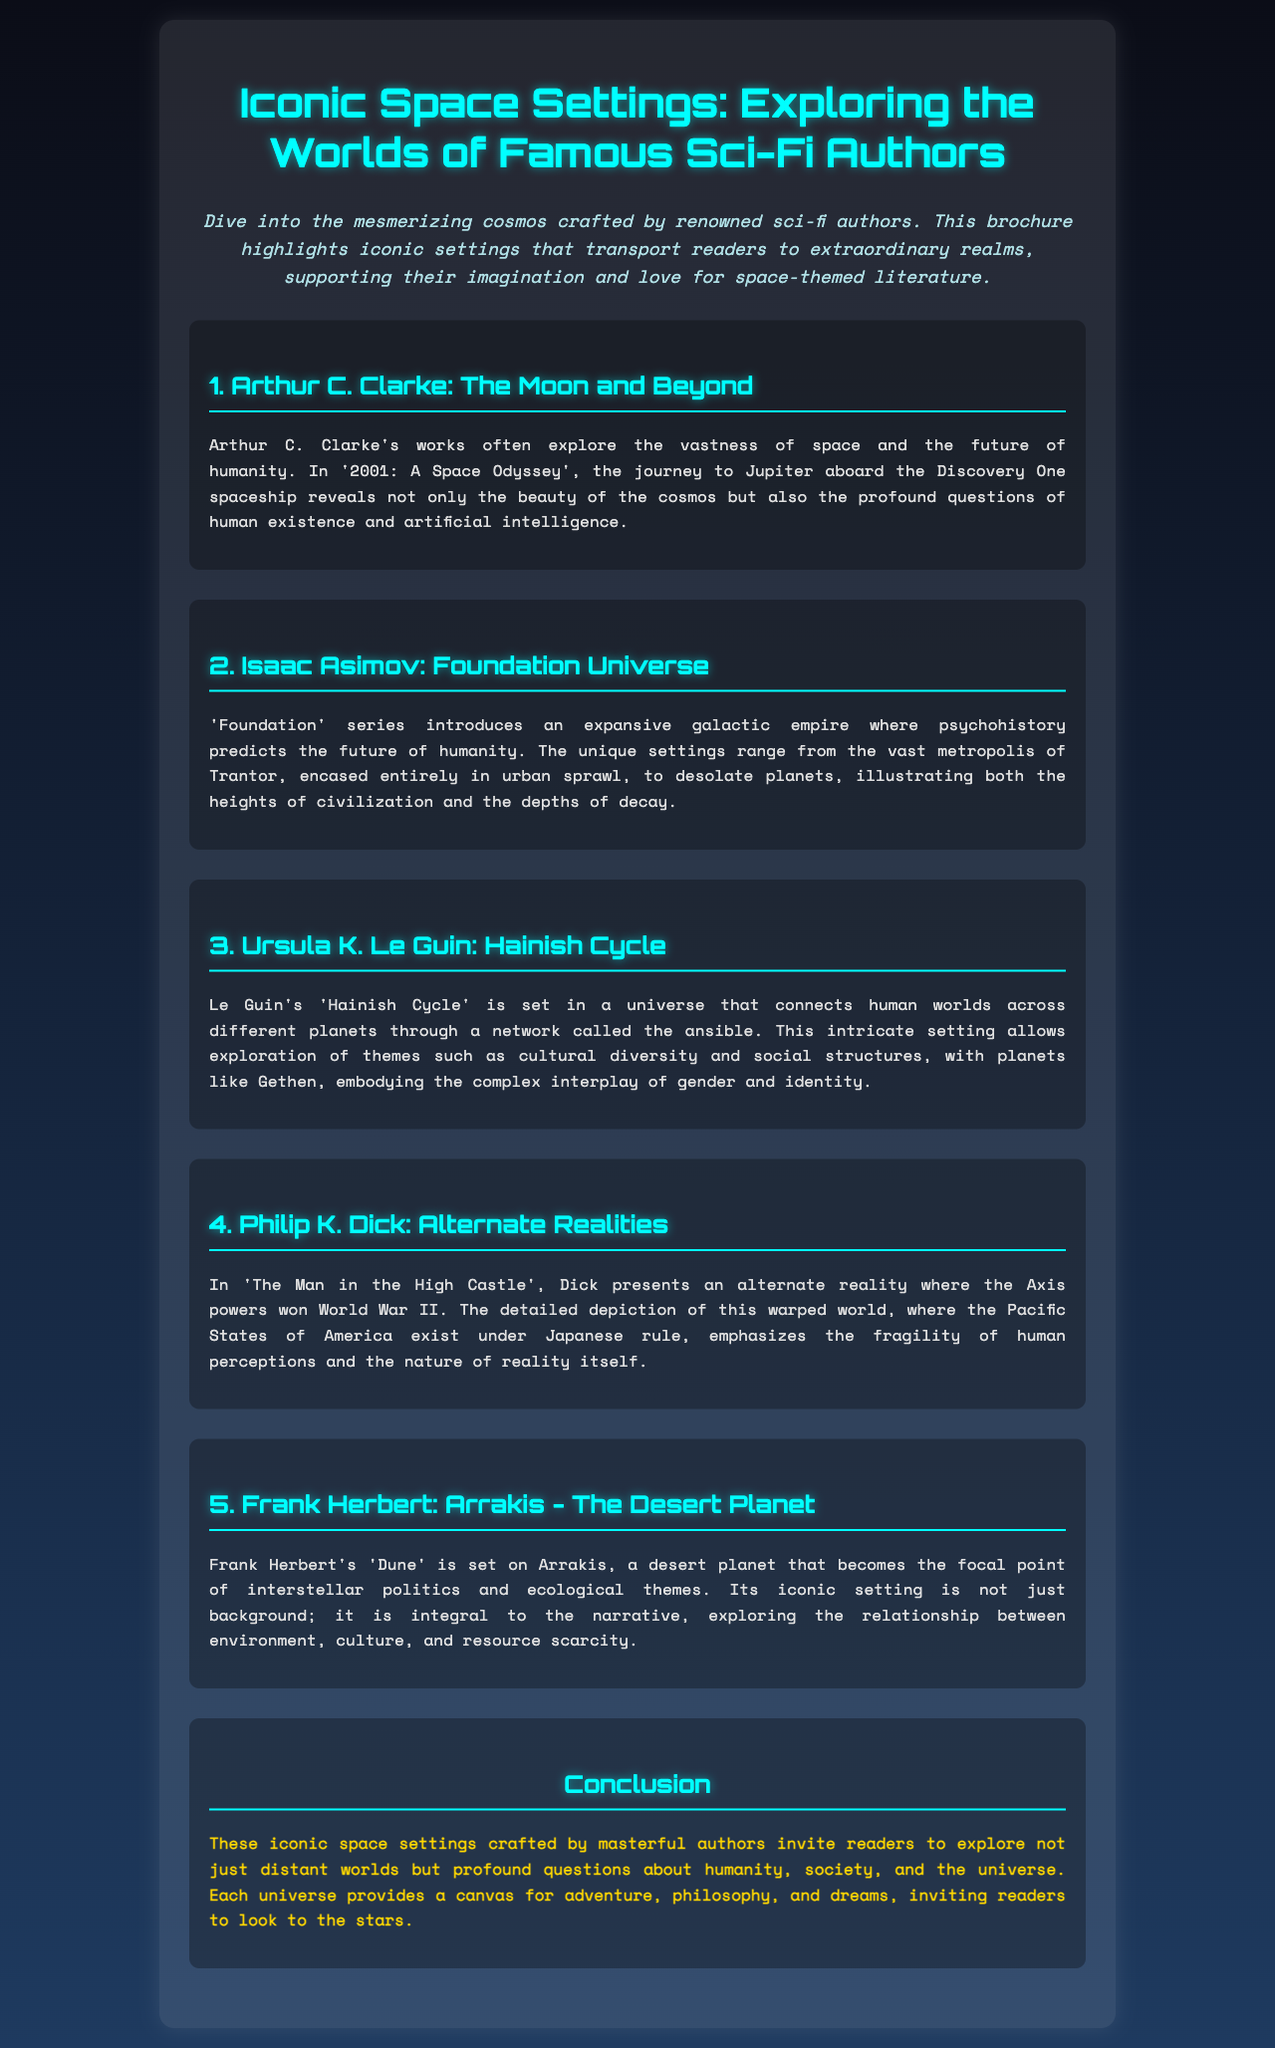What is the title of the brochure? The title is displayed prominently at the top of the document, stating "Iconic Space Settings: Exploring the Worlds of Famous Sci-Fi Authors."
Answer: Iconic Space Settings: Exploring the Worlds of Famous Sci-Fi Authors Who authored the 'Foundation' series? The document mentions Isaac Asimov as the author of the 'Foundation' series.
Answer: Isaac Asimov Which planet is central to Frank Herbert's 'Dune'? The section on Frank Herbert highlights Arrakis as the desert planet central to 'Dune'.
Answer: Arrakis What literary theme does Ursula K. Le Guin's 'Hainish Cycle' explore? The text indicates that it explores cultural diversity and social structures among other themes.
Answer: Cultural diversity and social structures How many authors are highlighted in the document? The brochure lists five authors, each with their own section.
Answer: Five What is the unique feature of Arthur C. Clarke's '2001: A Space Odyssey'? The document describes the story's journey to Jupiter revealing beauty and profound questions.
Answer: Journey to Jupiter What type of universe is featured in Philip K. Dick's 'The Man in the High Castle'? It presents an alternate reality where the Axis powers won World War II.
Answer: Alternate reality What conclusion can be drawn about the settings described in the brochure? The document states that these settings invite exploration of humanity, society, and the universe.
Answer: Exploration of humanity, society, and the universe Which author is associated with the concept of psychohistory? The author associated with psychohistory, as stated in the document, is Isaac Asimov.
Answer: Isaac Asimov 